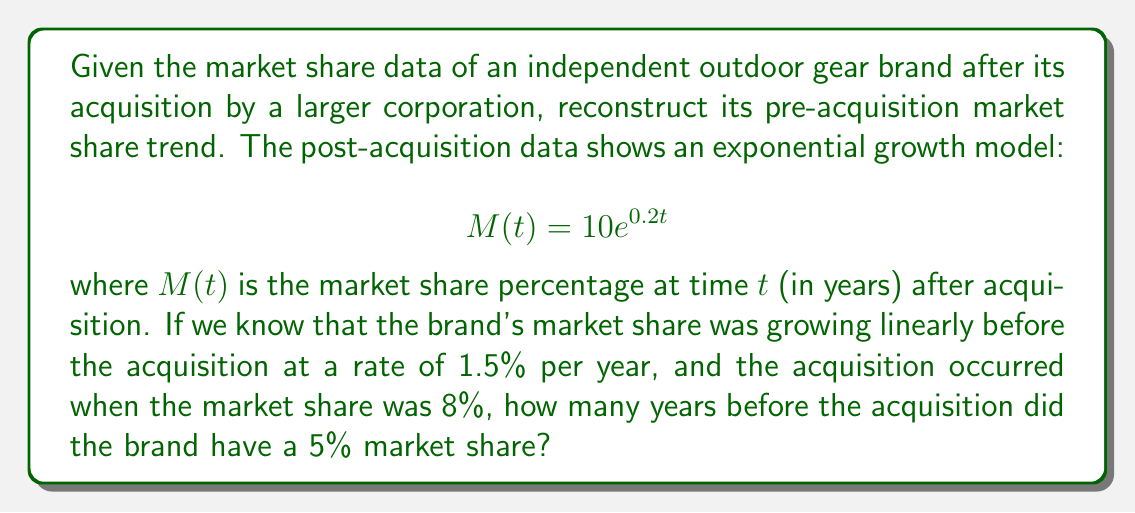Teach me how to tackle this problem. Let's approach this step-by-step:

1) First, we need to model the pre-acquisition market share. Given that it was growing linearly at 1.5% per year, we can express it as:

   $$S(t) = 1.5t + b$$

   where $S(t)$ is the market share percentage at time $t$ (in years) before acquisition, and $b$ is the y-intercept.

2) We know that at the time of acquisition ($t = 0$), the market share was 8%. So:

   $$8 = 1.5(0) + b$$
   $$b = 8$$

3) Therefore, our pre-acquisition model is:

   $$S(t) = 1.5t + 8$$

4) Now, we want to find when this model gave a 5% market share. Let's set up the equation:

   $$5 = 1.5t + 8$$

5) Solve for $t$:

   $$-3 = 1.5t$$
   $$t = -2$$

6) The negative value of $t$ indicates that this occurred before the acquisition (which is at $t = 0$).
Answer: 2 years 